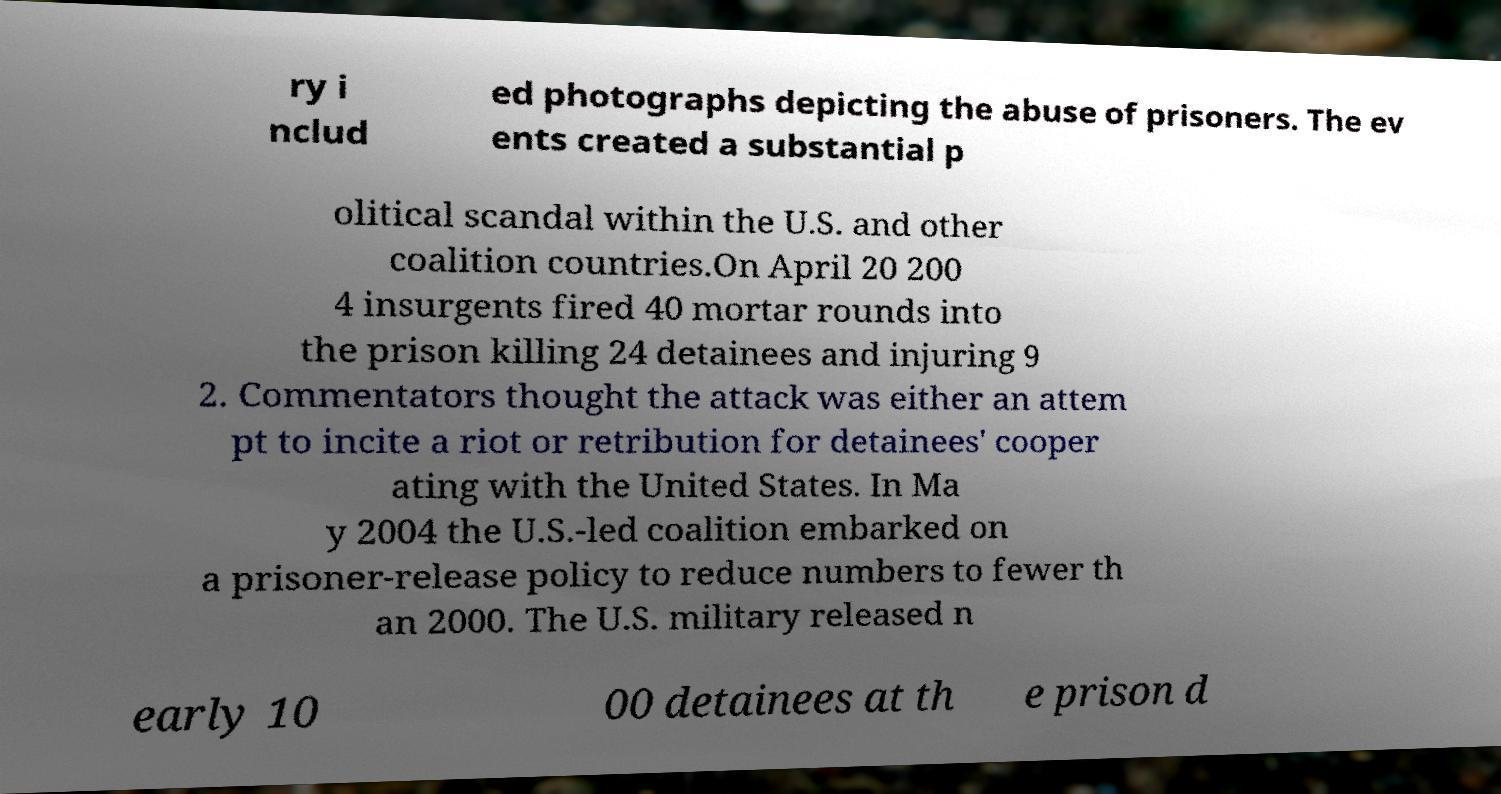Could you extract and type out the text from this image? ry i nclud ed photographs depicting the abuse of prisoners. The ev ents created a substantial p olitical scandal within the U.S. and other coalition countries.On April 20 200 4 insurgents fired 40 mortar rounds into the prison killing 24 detainees and injuring 9 2. Commentators thought the attack was either an attem pt to incite a riot or retribution for detainees' cooper ating with the United States. In Ma y 2004 the U.S.-led coalition embarked on a prisoner-release policy to reduce numbers to fewer th an 2000. The U.S. military released n early 10 00 detainees at th e prison d 